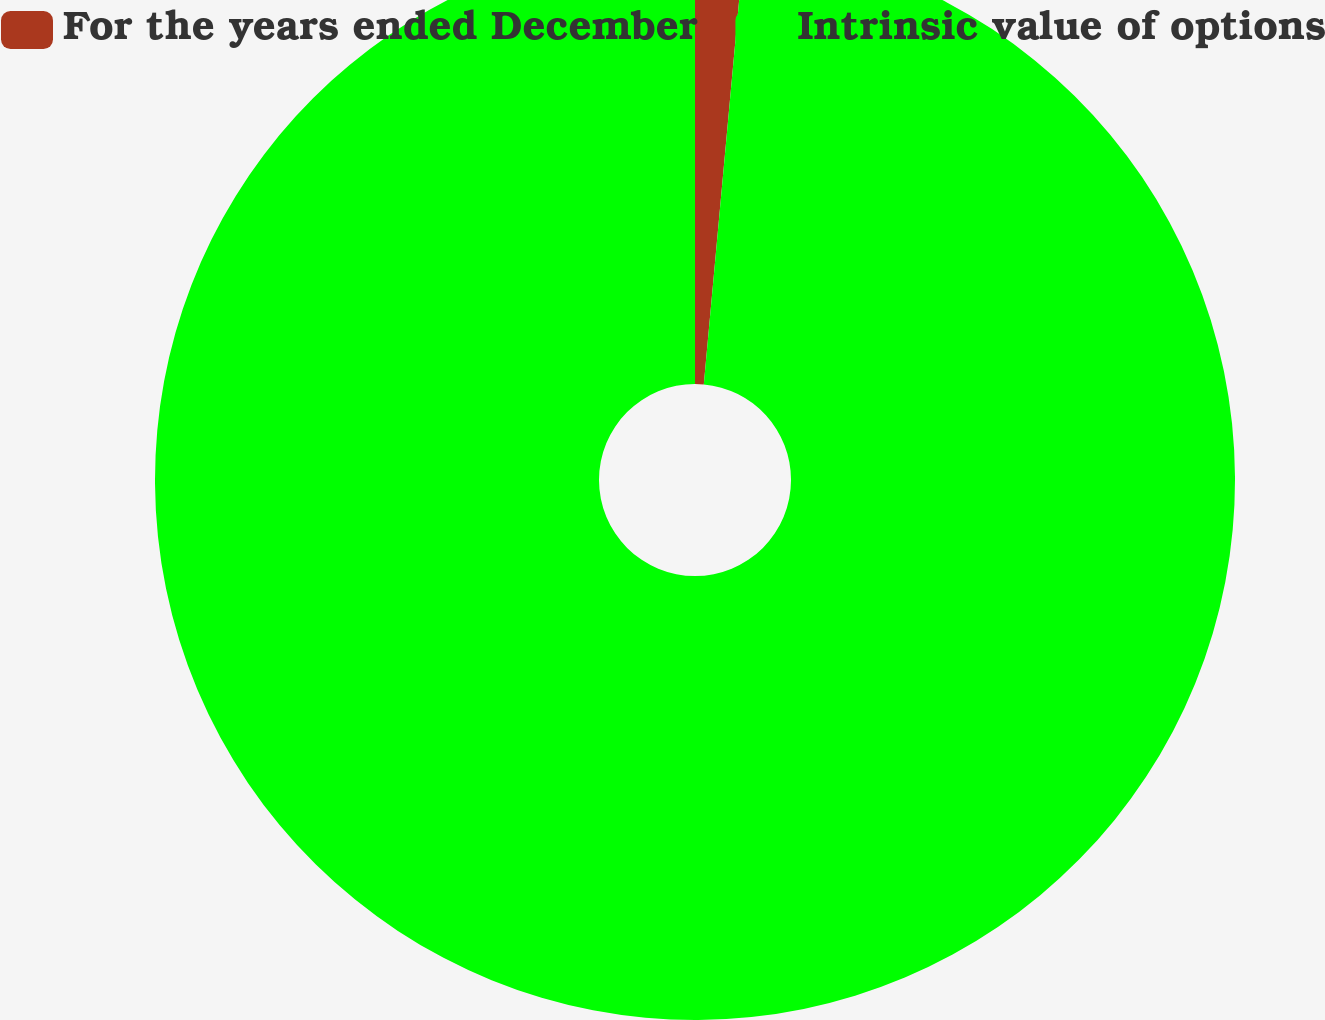Convert chart to OTSL. <chart><loc_0><loc_0><loc_500><loc_500><pie_chart><fcel>For the years ended December<fcel>Intrinsic value of options<nl><fcel>1.46%<fcel>98.54%<nl></chart> 